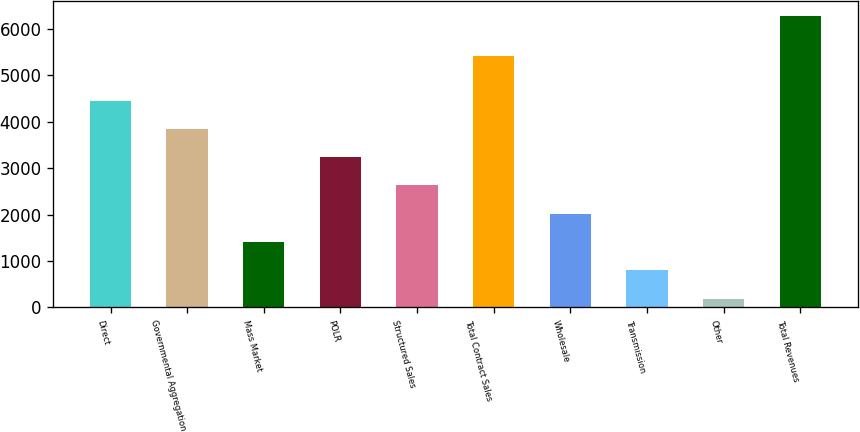Convert chart. <chart><loc_0><loc_0><loc_500><loc_500><bar_chart><fcel>Direct<fcel>Governmental Aggregation<fcel>Mass Market<fcel>POLR<fcel>Structured Sales<fcel>Total Contract Sales<fcel>Wholesale<fcel>Transmission<fcel>Other<fcel>Total Revenues<nl><fcel>4459<fcel>3849<fcel>1409<fcel>3239<fcel>2629<fcel>5419<fcel>2019<fcel>799<fcel>189<fcel>6289<nl></chart> 